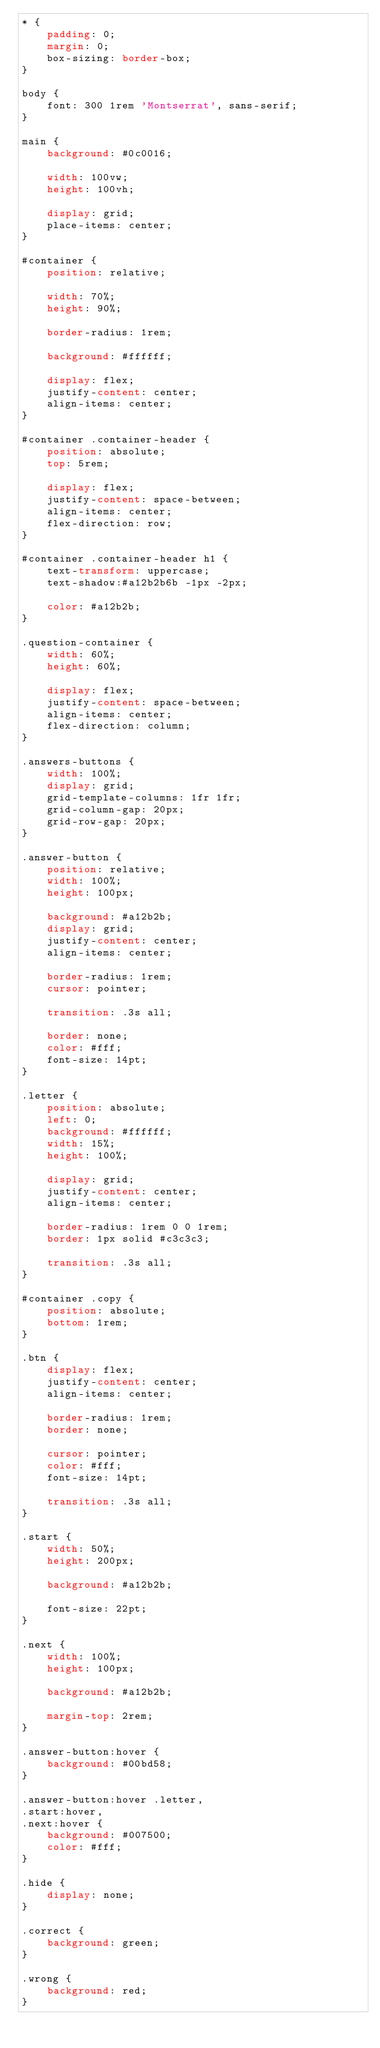<code> <loc_0><loc_0><loc_500><loc_500><_CSS_>* {
    padding: 0;
    margin: 0;
    box-sizing: border-box;
}

body {
    font: 300 1rem 'Montserrat', sans-serif;
}

main {
    background: #0c0016;

    width: 100vw;
    height: 100vh;

    display: grid;
    place-items: center;
}

#container {
    position: relative;

    width: 70%;
    height: 90%;

    border-radius: 1rem;

    background: #ffffff;

    display: flex;
    justify-content: center;
    align-items: center;
}

#container .container-header {
    position: absolute;
    top: 5rem;

    display: flex;
    justify-content: space-between;
    align-items: center;
    flex-direction: row;
}

#container .container-header h1 {   
    text-transform: uppercase;
    text-shadow:#a12b2b6b -1px -2px;
    
    color: #a12b2b;
}

.question-container {
    width: 60%;
    height: 60%;

    display: flex;
    justify-content: space-between;
    align-items: center;
    flex-direction: column;
}

.answers-buttons {
    width: 100%;
    display: grid;
    grid-template-columns: 1fr 1fr;
    grid-column-gap: 20px;
    grid-row-gap: 20px;
}

.answer-button {
    position: relative;
    width: 100%;
    height: 100px;

    background: #a12b2b;
    display: grid;
    justify-content: center;
    align-items: center;

    border-radius: 1rem;
    cursor: pointer;

    transition: .3s all;

    border: none;
    color: #fff;
    font-size: 14pt;
}

.letter {
    position: absolute;
    left: 0;
    background: #ffffff;
    width: 15%;
    height: 100%;

    display: grid;
    justify-content: center;
    align-items: center;

    border-radius: 1rem 0 0 1rem;
    border: 1px solid #c3c3c3;

    transition: .3s all;
}

#container .copy {
    position: absolute;
    bottom: 1rem;
}

.btn {
    display: flex;
    justify-content: center;
    align-items: center;

    border-radius: 1rem;
    border: none;

    cursor: pointer;
    color: #fff;
    font-size: 14pt;

    transition: .3s all;
}

.start {
    width: 50%;
    height: 200px;

    background: #a12b2b;

    font-size: 22pt;
}

.next {    
    width: 100%;
    height: 100px;

    background: #a12b2b;
    
    margin-top: 2rem;
}

.answer-button:hover {
    background: #00bd58;
}

.answer-button:hover .letter,
.start:hover,
.next:hover {
    background: #007500;
    color: #fff;
}

.hide {
    display: none;
}

.correct {
    background: green;
}

.wrong {
    background: red;    
}</code> 